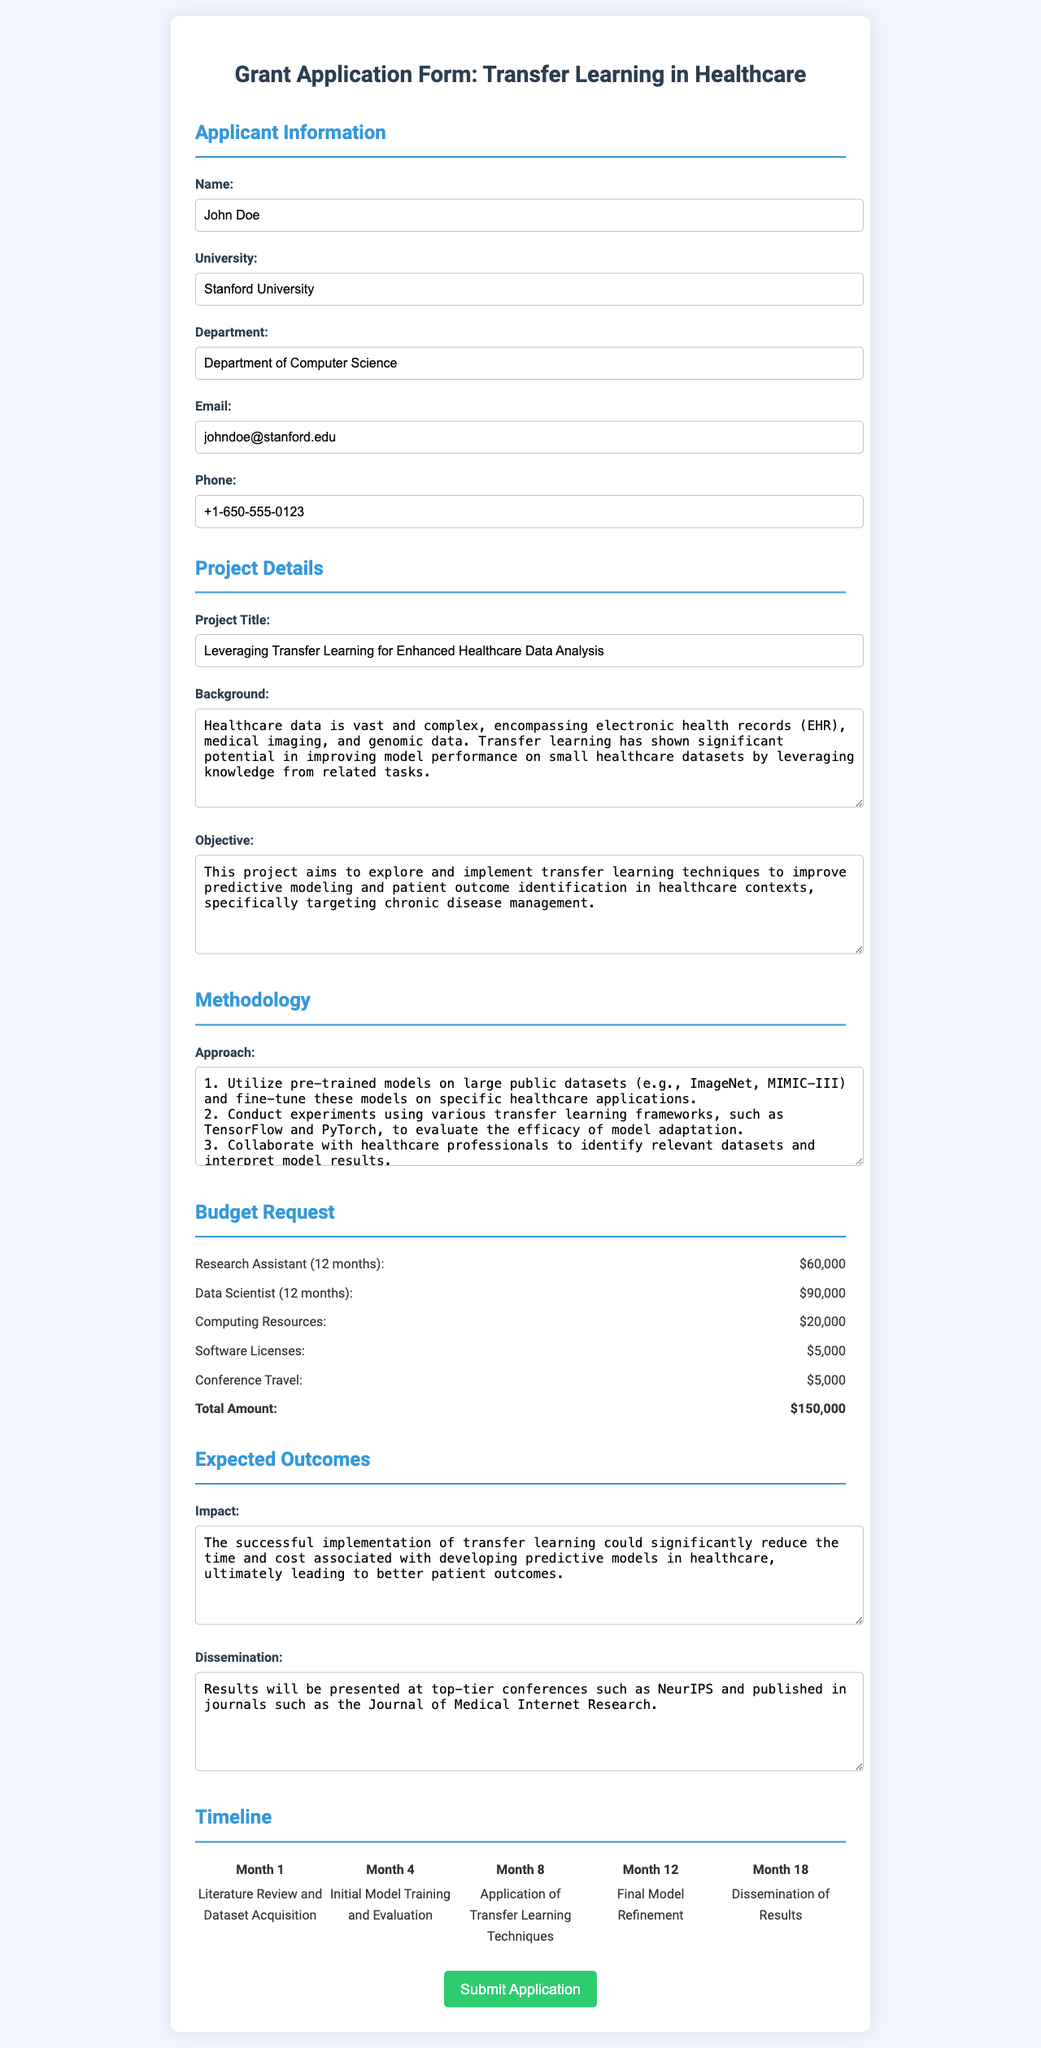What is the applicant's name? The applicant's name provided in the document is John Doe.
Answer: John Doe What is the total budget requested for the project? The total budget requested is listed at the end of the budget section as $150,000.
Answer: $150,000 What is the project's main objective? The project objective is detailed in the document, emphasizing the use of transfer learning for predictive modeling in chronic disease management.
Answer: Improve predictive modeling and patient outcome identification What university is the applicant affiliated with? The document specifies the applicant's university as Stanford University.
Answer: Stanford University What is the first task outlined in the project timeline? The timeline indicates that the first task is to perform a literature review and dataset acquisition in Month 1.
Answer: Literature Review and Dataset Acquisition How many months does the project span? By reviewing the timeline, it can be inferred that the project spans from Month 1 to Month 18, totaling 18 months.
Answer: 18 months What is one anticipated impact of the project? The impact discussed in this project is related to the improvement of patient outcomes through enhanced predictive models.
Answer: Better patient outcomes Where will the results of the project be disseminated? The dissemination of results is planned for presentation at NeurIPS and publication in the Journal of Medical Internet Research.
Answer: NeurIPS and Journal of Medical Internet Research How many budget items are listed in the budget request section? The budget request section includes five individual budget items as detailed in the document.
Answer: Five 